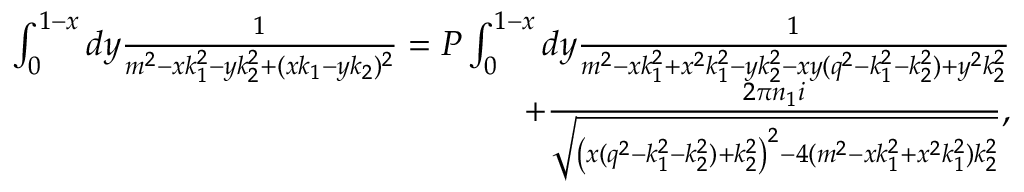Convert formula to latex. <formula><loc_0><loc_0><loc_500><loc_500>\begin{array} { r l r } & { \int _ { 0 } ^ { 1 - x } d y \frac { 1 } { m ^ { 2 } - x k _ { 1 } ^ { 2 } - y k _ { 2 } ^ { 2 } + ( x k _ { 1 } - y k _ { 2 } ) ^ { 2 } } = P \int _ { 0 } ^ { 1 - x } d y \frac { 1 } { m ^ { 2 } - x k _ { 1 } ^ { 2 } + x ^ { 2 } k _ { 1 } ^ { 2 } - y k _ { 2 } ^ { 2 } - x y ( q ^ { 2 } - k _ { 1 } ^ { 2 } - k _ { 2 } ^ { 2 } ) + y ^ { 2 } k _ { 2 } ^ { 2 } } } \\ & { + \frac { 2 \pi n _ { 1 } i } { \sqrt { \left ( x ( q ^ { 2 } - k _ { 1 } ^ { 2 } - k _ { 2 } ^ { 2 } ) + k _ { 2 } ^ { 2 } \right ) ^ { 2 } - 4 ( m ^ { 2 } - x k _ { 1 } ^ { 2 } + x ^ { 2 } k _ { 1 } ^ { 2 } ) k _ { 2 } ^ { 2 } } } , } \end{array}</formula> 